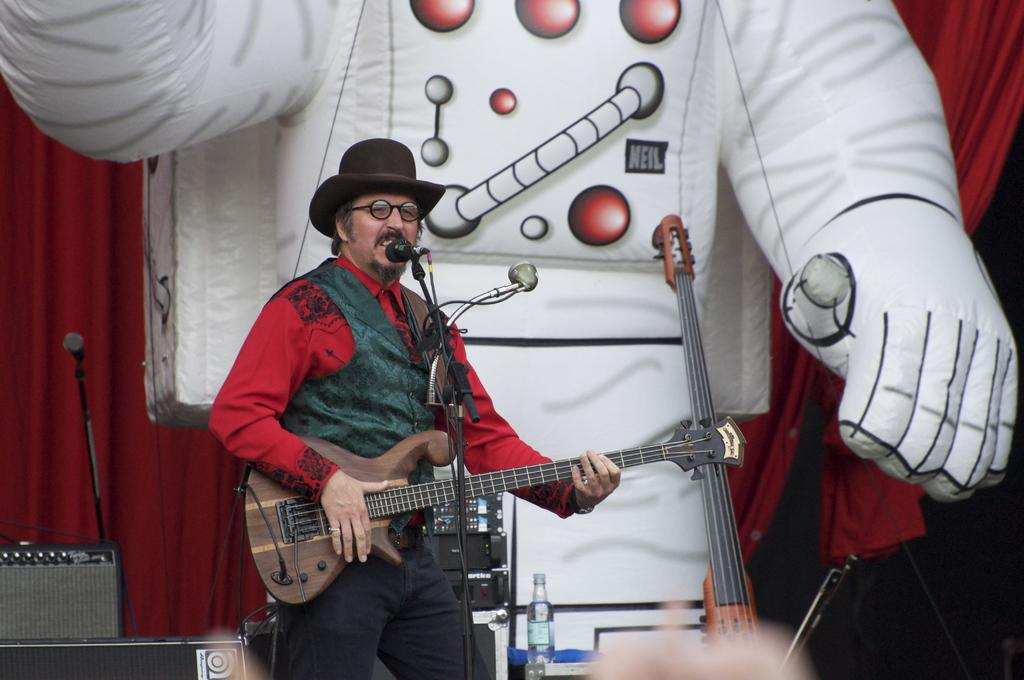What is the man in the image doing? The man is playing a guitar in the image. What objects can be seen in the background of the image? There is a bottle, a microphone, and a toy in the background of the image. What color is the curtain in the image? There is a red curtain in the image. What type of toothpaste is the man using while playing the guitar in the image? There is no toothpaste present in the image, and the man is not using any while playing the guitar. 